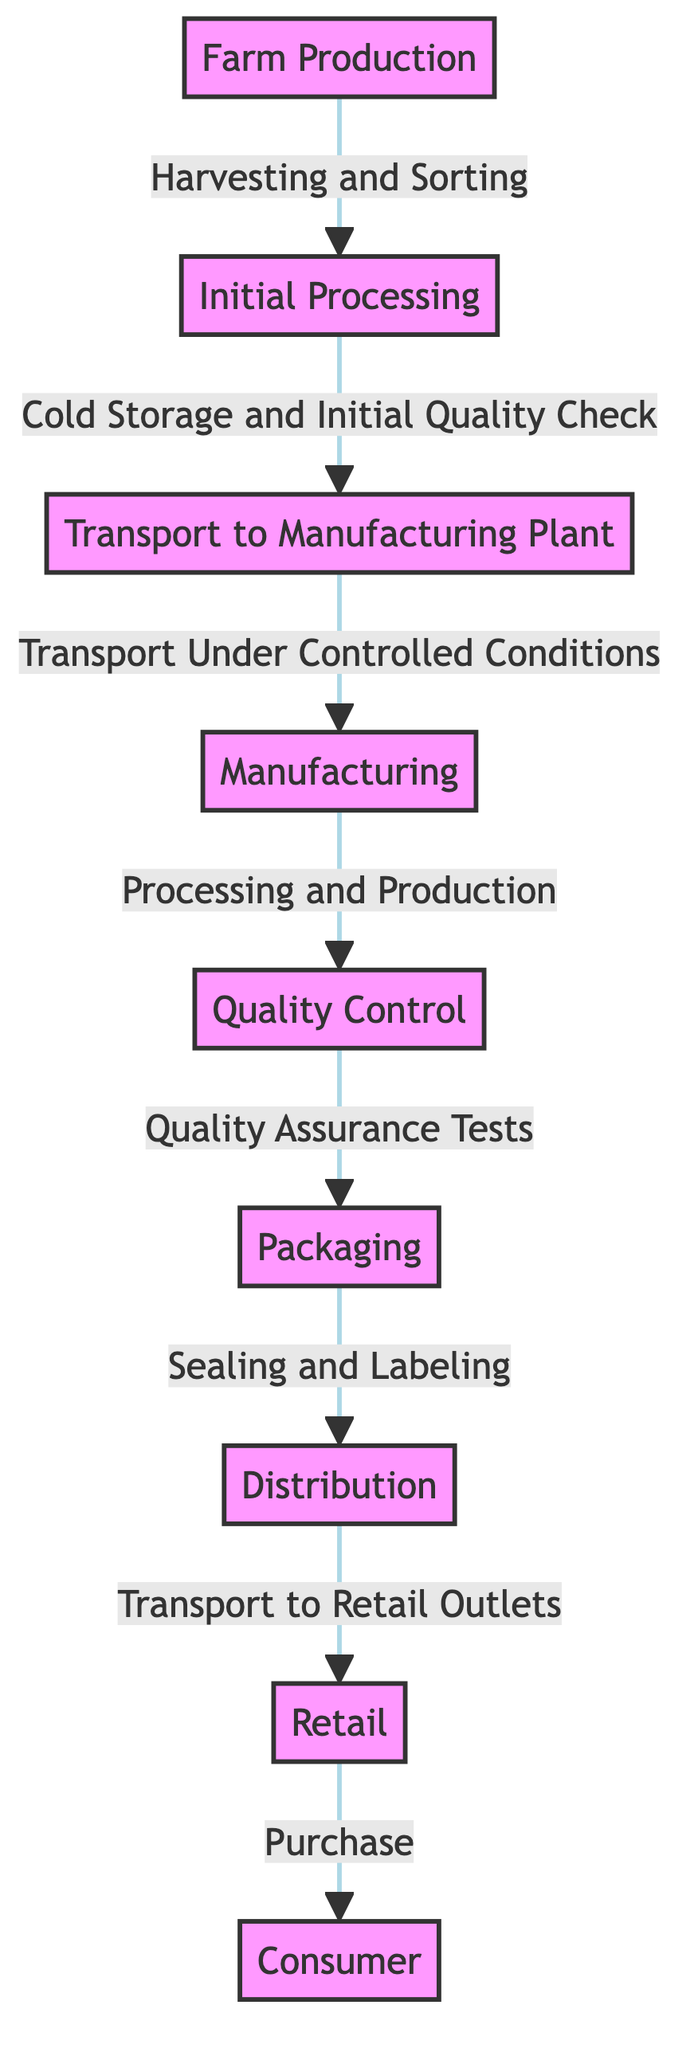What is the first step in the food supply chain? The first node in the diagram is "Farm Production", indicating that this is the starting point of the process.
Answer: Farm Production How many nodes are in the diagram? Counting all the visible nodes in the diagram, we identify a total of 9 distinct nodes.
Answer: 9 What process occurs after Initial Processing? The sequence of the arrows shows the direct flow from "Initial Processing" to "Transport to Manufacturing Plant".
Answer: Transport to Manufacturing Plant What type of checks are performed during Quality Control? The text associated with the Quality Control node states that "Quality Assurance Tests" are performed.
Answer: Quality Assurance Tests What happens to the product after Packaging? The flow from the node "Packaging" leads directly to "Distribution", meaning the product is distributed after packaging.
Answer: Distribution Which process comes before Retail? Looking at the diagram, the node "Distribution" directly leads to "Retail" which indicates Distribution comes before Retail.
Answer: Distribution What is the final stage of the food supply chain? The last node in the flowchart is "Consumer", showing that this is the endpoint of the food supply chain.
Answer: Consumer How is the product transported from the farm to the manufacturing plant? According to the diagram, the product is transported "Under Controlled Conditions" from "Transport to Manufacturing Plant".
Answer: Under Controlled Conditions What occurs between Manufacturing and Packaging? The arrow indicates that after "Manufacturing", the next process is "Quality Control", which separates Manufacturing from Packaging.
Answer: Quality Control 